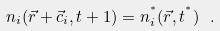Convert formula to latex. <formula><loc_0><loc_0><loc_500><loc_500>n _ { i } ( \vec { r } + \vec { c } _ { i } , t + 1 ) = n _ { i } ^ { ^ { * } } ( \vec { r } , t ^ { ^ { * } } ) \ .</formula> 